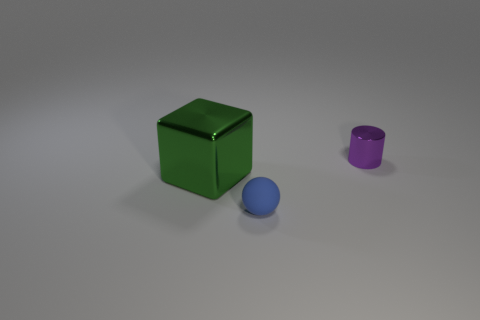Is there any other thing that has the same material as the tiny blue ball?
Give a very brief answer. No. What number of large green metallic objects are behind the small object that is left of the small purple thing?
Your response must be concise. 1. What size is the cylinder that is the same material as the large block?
Offer a terse response. Small. How big is the cube?
Your response must be concise. Large. Do the tiny purple thing and the big green block have the same material?
Give a very brief answer. Yes. How many blocks are metallic things or cyan matte objects?
Offer a very short reply. 1. What is the color of the small object that is in front of the object that is behind the green metallic block?
Keep it short and to the point. Blue. There is a thing that is to the left of the object in front of the large green shiny object; how many purple cylinders are in front of it?
Your response must be concise. 0. What number of things are either yellow shiny cubes or large cubes?
Keep it short and to the point. 1. What material is the small thing that is behind the metallic object that is left of the tiny metallic object?
Your answer should be very brief. Metal. 